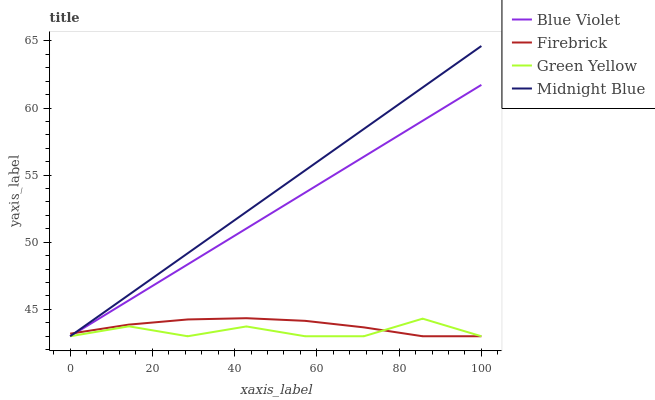Does Green Yellow have the minimum area under the curve?
Answer yes or no. Yes. Does Midnight Blue have the maximum area under the curve?
Answer yes or no. Yes. Does Midnight Blue have the minimum area under the curve?
Answer yes or no. No. Does Green Yellow have the maximum area under the curve?
Answer yes or no. No. Is Midnight Blue the smoothest?
Answer yes or no. Yes. Is Green Yellow the roughest?
Answer yes or no. Yes. Is Green Yellow the smoothest?
Answer yes or no. No. Is Midnight Blue the roughest?
Answer yes or no. No. Does Firebrick have the lowest value?
Answer yes or no. Yes. Does Midnight Blue have the highest value?
Answer yes or no. Yes. Does Green Yellow have the highest value?
Answer yes or no. No. Does Green Yellow intersect Midnight Blue?
Answer yes or no. Yes. Is Green Yellow less than Midnight Blue?
Answer yes or no. No. Is Green Yellow greater than Midnight Blue?
Answer yes or no. No. 